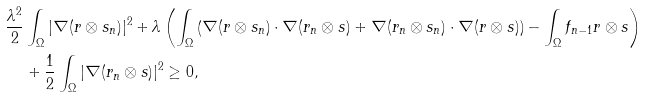Convert formula to latex. <formula><loc_0><loc_0><loc_500><loc_500>\frac { \lambda ^ { 2 } } { 2 } & \int _ { \Omega } | \nabla ( r \otimes s _ { n } ) | ^ { 2 } + \lambda \left ( \int _ { \Omega } \left ( \nabla ( r \otimes s _ { n } ) \cdot \nabla ( r _ { n } \otimes s ) + \nabla ( r _ { n } \otimes s _ { n } ) \cdot \nabla ( r \otimes s ) \right ) - \int _ { \Omega } f _ { n - 1 } r \otimes s \right ) \\ & + \frac { 1 } { 2 } \int _ { \Omega } | \nabla ( r _ { n } \otimes s ) | ^ { 2 } \geq 0 ,</formula> 